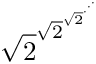<formula> <loc_0><loc_0><loc_500><loc_500>{ \sqrt { 2 } } ^ { { \sqrt { 2 } } ^ { { \sqrt { 2 } } ^ { \cdot ^ { \cdot ^ { \cdot } } } } }</formula> 